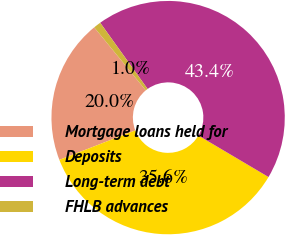Convert chart. <chart><loc_0><loc_0><loc_500><loc_500><pie_chart><fcel>Mortgage loans held for<fcel>Deposits<fcel>Long-term debt<fcel>FHLB advances<nl><fcel>19.98%<fcel>35.59%<fcel>43.39%<fcel>1.03%<nl></chart> 